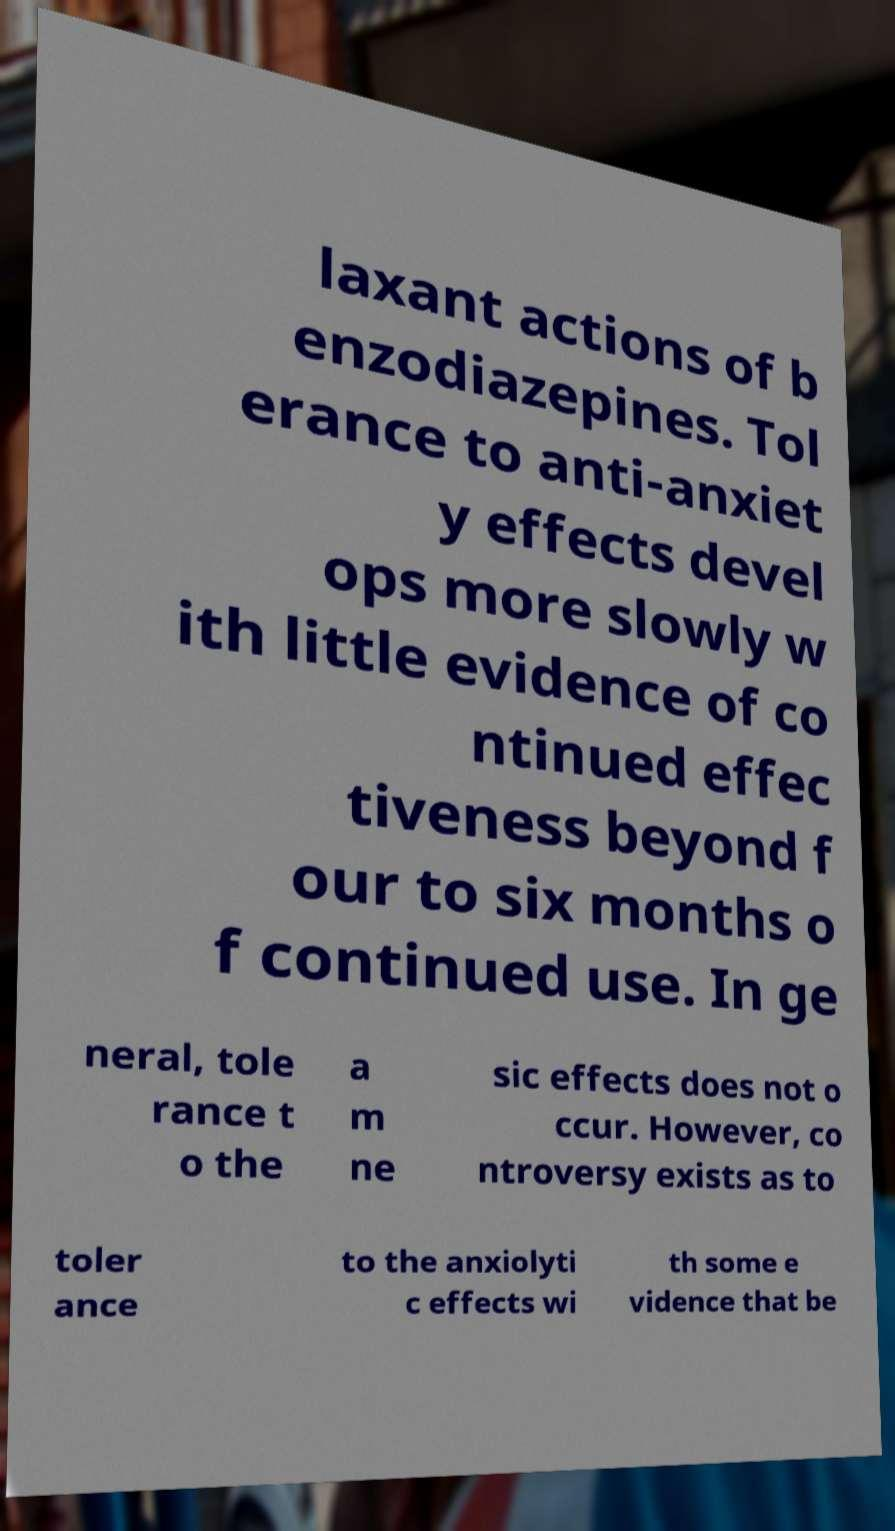Can you read and provide the text displayed in the image?This photo seems to have some interesting text. Can you extract and type it out for me? laxant actions of b enzodiazepines. Tol erance to anti-anxiet y effects devel ops more slowly w ith little evidence of co ntinued effec tiveness beyond f our to six months o f continued use. In ge neral, tole rance t o the a m ne sic effects does not o ccur. However, co ntroversy exists as to toler ance to the anxiolyti c effects wi th some e vidence that be 